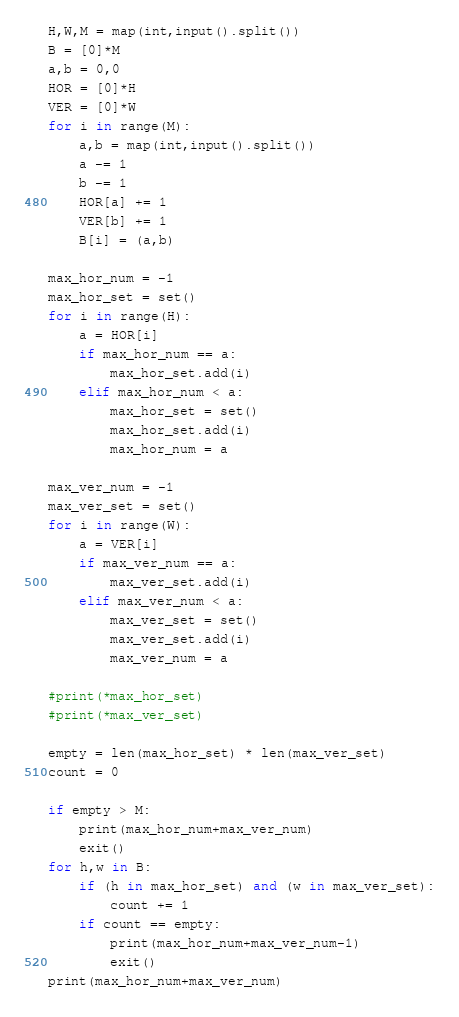<code> <loc_0><loc_0><loc_500><loc_500><_Python_>H,W,M = map(int,input().split())
B = [0]*M
a,b = 0,0
HOR = [0]*H
VER = [0]*W
for i in range(M):
    a,b = map(int,input().split())
    a -= 1
    b -= 1
    HOR[a] += 1
    VER[b] += 1
    B[i] = (a,b)

max_hor_num = -1
max_hor_set = set()
for i in range(H):
    a = HOR[i]
    if max_hor_num == a:
        max_hor_set.add(i)
    elif max_hor_num < a:
        max_hor_set = set()
        max_hor_set.add(i)
        max_hor_num = a

max_ver_num = -1
max_ver_set = set()
for i in range(W):
    a = VER[i]
    if max_ver_num == a:
        max_ver_set.add(i)
    elif max_ver_num < a:
        max_ver_set = set()
        max_ver_set.add(i)
        max_ver_num = a

#print(*max_hor_set)
#print(*max_ver_set)

empty = len(max_hor_set) * len(max_ver_set)
count = 0

if empty > M:
    print(max_hor_num+max_ver_num)
    exit()
for h,w in B:
    if (h in max_hor_set) and (w in max_ver_set):
        count += 1
    if count == empty:
        print(max_hor_num+max_ver_num-1)
        exit()
print(max_hor_num+max_ver_num)</code> 